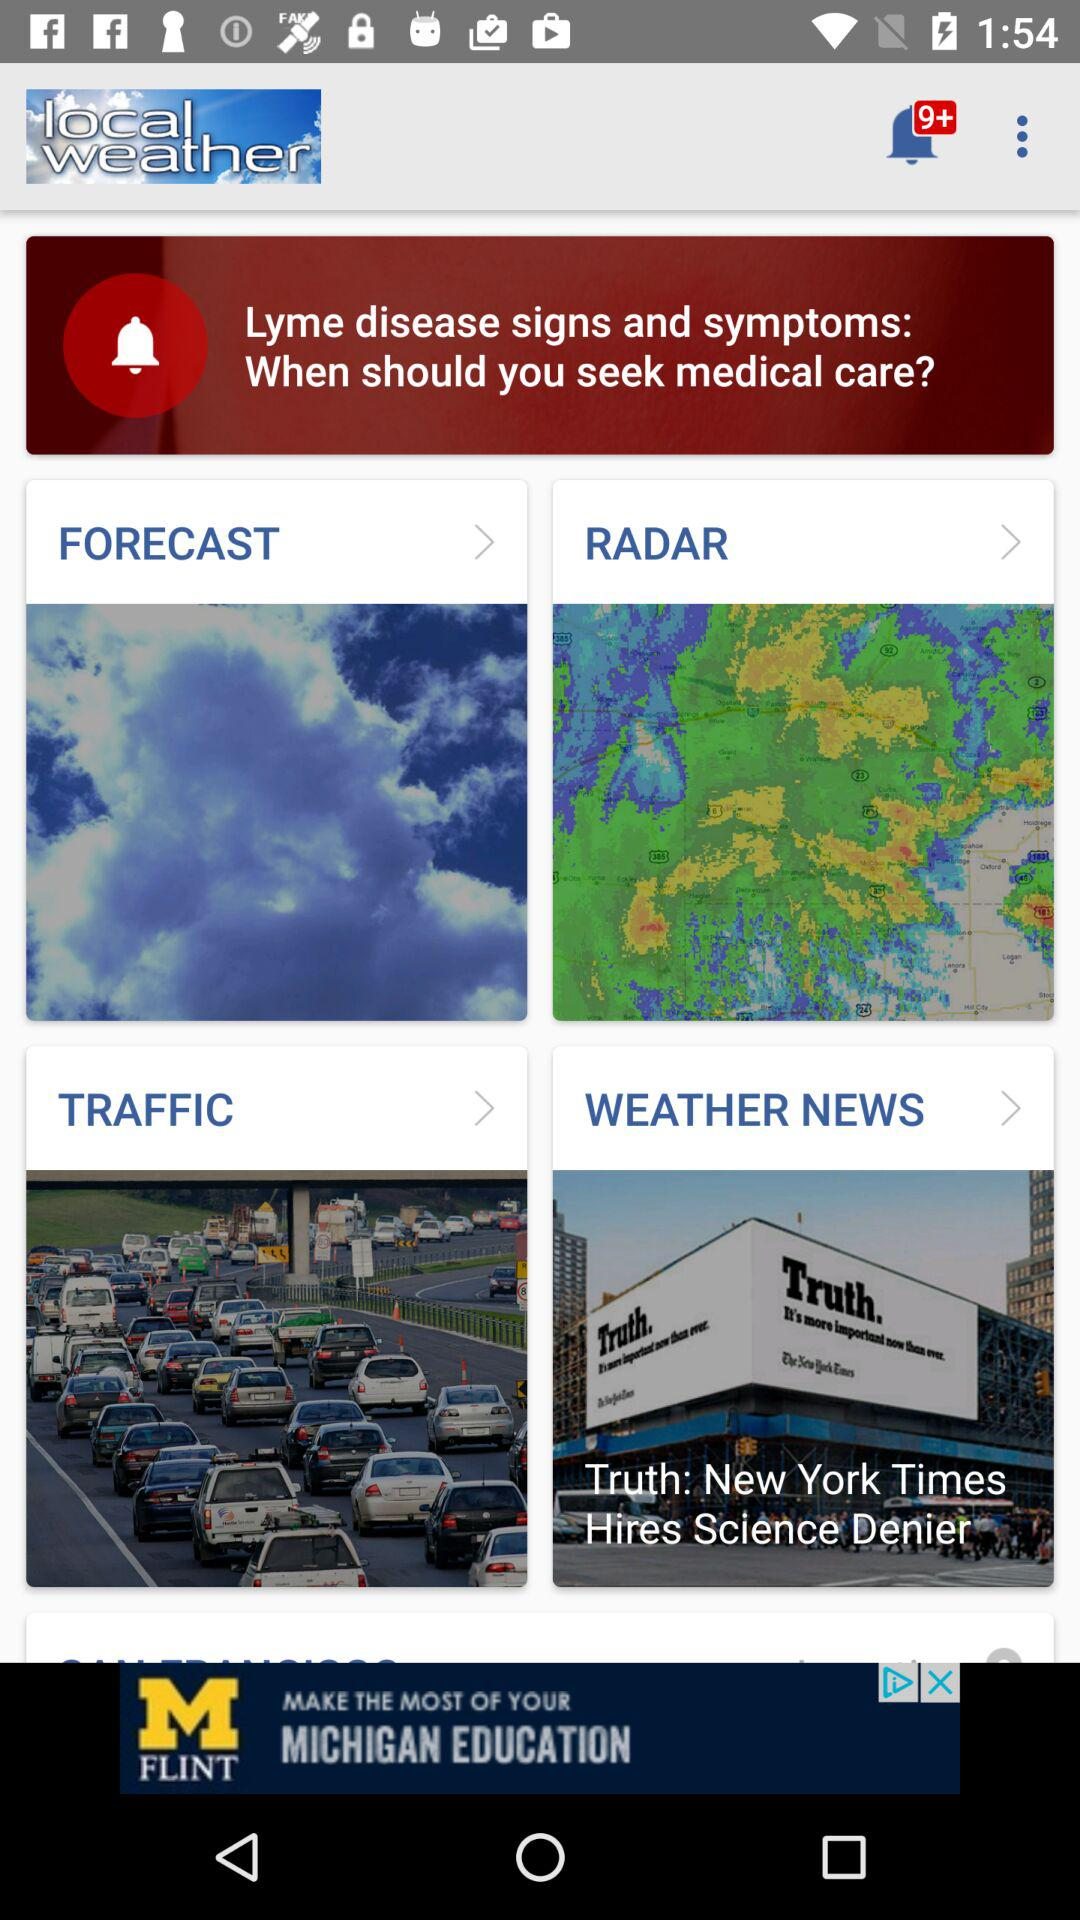What is the application name? The application name is "local weather". 